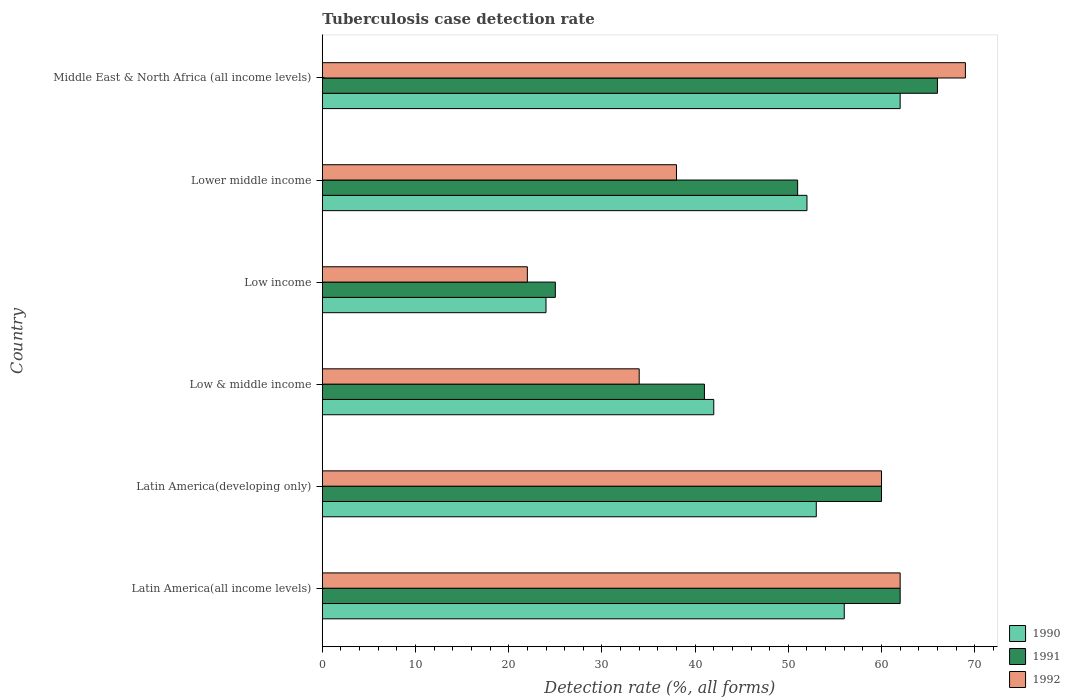How many different coloured bars are there?
Provide a short and direct response. 3. How many groups of bars are there?
Ensure brevity in your answer.  6. Are the number of bars per tick equal to the number of legend labels?
Give a very brief answer. Yes. Are the number of bars on each tick of the Y-axis equal?
Give a very brief answer. Yes. How many bars are there on the 5th tick from the bottom?
Provide a succinct answer. 3. Across all countries, what is the maximum tuberculosis case detection rate in in 1991?
Ensure brevity in your answer.  66. Across all countries, what is the minimum tuberculosis case detection rate in in 1991?
Give a very brief answer. 25. In which country was the tuberculosis case detection rate in in 1992 maximum?
Make the answer very short. Middle East & North Africa (all income levels). What is the total tuberculosis case detection rate in in 1991 in the graph?
Provide a succinct answer. 305. What is the average tuberculosis case detection rate in in 1992 per country?
Keep it short and to the point. 47.5. In how many countries, is the tuberculosis case detection rate in in 1990 greater than 60 %?
Provide a succinct answer. 1. What is the ratio of the tuberculosis case detection rate in in 1991 in Latin America(all income levels) to that in Middle East & North Africa (all income levels)?
Provide a succinct answer. 0.94. Is the difference between the tuberculosis case detection rate in in 1992 in Latin America(developing only) and Low income greater than the difference between the tuberculosis case detection rate in in 1991 in Latin America(developing only) and Low income?
Provide a succinct answer. Yes. Is the sum of the tuberculosis case detection rate in in 1991 in Lower middle income and Middle East & North Africa (all income levels) greater than the maximum tuberculosis case detection rate in in 1992 across all countries?
Make the answer very short. Yes. What does the 1st bar from the top in Middle East & North Africa (all income levels) represents?
Provide a short and direct response. 1992. How many bars are there?
Give a very brief answer. 18. Are all the bars in the graph horizontal?
Offer a terse response. Yes. How many countries are there in the graph?
Keep it short and to the point. 6. Does the graph contain any zero values?
Provide a short and direct response. No. How many legend labels are there?
Offer a terse response. 3. What is the title of the graph?
Make the answer very short. Tuberculosis case detection rate. Does "1999" appear as one of the legend labels in the graph?
Provide a succinct answer. No. What is the label or title of the X-axis?
Give a very brief answer. Detection rate (%, all forms). What is the Detection rate (%, all forms) of 1990 in Latin America(developing only)?
Keep it short and to the point. 53. What is the Detection rate (%, all forms) of 1991 in Latin America(developing only)?
Your answer should be compact. 60. What is the Detection rate (%, all forms) of 1991 in Low & middle income?
Give a very brief answer. 41. What is the Detection rate (%, all forms) in 1992 in Low & middle income?
Make the answer very short. 34. What is the Detection rate (%, all forms) in 1990 in Low income?
Your answer should be very brief. 24. What is the Detection rate (%, all forms) in 1992 in Low income?
Ensure brevity in your answer.  22. What is the Detection rate (%, all forms) in 1992 in Lower middle income?
Keep it short and to the point. 38. What is the Detection rate (%, all forms) of 1991 in Middle East & North Africa (all income levels)?
Provide a short and direct response. 66. What is the Detection rate (%, all forms) in 1992 in Middle East & North Africa (all income levels)?
Make the answer very short. 69. Across all countries, what is the maximum Detection rate (%, all forms) of 1990?
Your response must be concise. 62. Across all countries, what is the minimum Detection rate (%, all forms) in 1990?
Provide a succinct answer. 24. Across all countries, what is the minimum Detection rate (%, all forms) of 1991?
Keep it short and to the point. 25. What is the total Detection rate (%, all forms) in 1990 in the graph?
Your answer should be compact. 289. What is the total Detection rate (%, all forms) in 1991 in the graph?
Your answer should be compact. 305. What is the total Detection rate (%, all forms) in 1992 in the graph?
Offer a terse response. 285. What is the difference between the Detection rate (%, all forms) in 1990 in Latin America(all income levels) and that in Latin America(developing only)?
Keep it short and to the point. 3. What is the difference between the Detection rate (%, all forms) of 1991 in Latin America(all income levels) and that in Latin America(developing only)?
Offer a terse response. 2. What is the difference between the Detection rate (%, all forms) of 1992 in Latin America(all income levels) and that in Latin America(developing only)?
Ensure brevity in your answer.  2. What is the difference between the Detection rate (%, all forms) in 1991 in Latin America(all income levels) and that in Low & middle income?
Provide a succinct answer. 21. What is the difference between the Detection rate (%, all forms) in 1992 in Latin America(all income levels) and that in Low income?
Provide a short and direct response. 40. What is the difference between the Detection rate (%, all forms) of 1990 in Latin America(all income levels) and that in Lower middle income?
Your response must be concise. 4. What is the difference between the Detection rate (%, all forms) of 1991 in Latin America(all income levels) and that in Lower middle income?
Offer a terse response. 11. What is the difference between the Detection rate (%, all forms) in 1992 in Latin America(all income levels) and that in Lower middle income?
Your answer should be compact. 24. What is the difference between the Detection rate (%, all forms) in 1991 in Latin America(all income levels) and that in Middle East & North Africa (all income levels)?
Keep it short and to the point. -4. What is the difference between the Detection rate (%, all forms) of 1992 in Latin America(all income levels) and that in Middle East & North Africa (all income levels)?
Offer a very short reply. -7. What is the difference between the Detection rate (%, all forms) of 1990 in Latin America(developing only) and that in Low & middle income?
Your answer should be very brief. 11. What is the difference between the Detection rate (%, all forms) of 1991 in Latin America(developing only) and that in Low & middle income?
Offer a very short reply. 19. What is the difference between the Detection rate (%, all forms) of 1990 in Latin America(developing only) and that in Low income?
Keep it short and to the point. 29. What is the difference between the Detection rate (%, all forms) in 1992 in Latin America(developing only) and that in Low income?
Your response must be concise. 38. What is the difference between the Detection rate (%, all forms) of 1990 in Latin America(developing only) and that in Lower middle income?
Offer a terse response. 1. What is the difference between the Detection rate (%, all forms) in 1991 in Latin America(developing only) and that in Middle East & North Africa (all income levels)?
Keep it short and to the point. -6. What is the difference between the Detection rate (%, all forms) of 1992 in Latin America(developing only) and that in Middle East & North Africa (all income levels)?
Your response must be concise. -9. What is the difference between the Detection rate (%, all forms) in 1990 in Low & middle income and that in Low income?
Give a very brief answer. 18. What is the difference between the Detection rate (%, all forms) of 1990 in Low & middle income and that in Lower middle income?
Your answer should be compact. -10. What is the difference between the Detection rate (%, all forms) of 1992 in Low & middle income and that in Lower middle income?
Provide a succinct answer. -4. What is the difference between the Detection rate (%, all forms) in 1991 in Low & middle income and that in Middle East & North Africa (all income levels)?
Offer a terse response. -25. What is the difference between the Detection rate (%, all forms) of 1992 in Low & middle income and that in Middle East & North Africa (all income levels)?
Your answer should be compact. -35. What is the difference between the Detection rate (%, all forms) of 1992 in Low income and that in Lower middle income?
Your response must be concise. -16. What is the difference between the Detection rate (%, all forms) in 1990 in Low income and that in Middle East & North Africa (all income levels)?
Provide a short and direct response. -38. What is the difference between the Detection rate (%, all forms) in 1991 in Low income and that in Middle East & North Africa (all income levels)?
Keep it short and to the point. -41. What is the difference between the Detection rate (%, all forms) of 1992 in Low income and that in Middle East & North Africa (all income levels)?
Your response must be concise. -47. What is the difference between the Detection rate (%, all forms) in 1990 in Lower middle income and that in Middle East & North Africa (all income levels)?
Your answer should be very brief. -10. What is the difference between the Detection rate (%, all forms) in 1992 in Lower middle income and that in Middle East & North Africa (all income levels)?
Offer a very short reply. -31. What is the difference between the Detection rate (%, all forms) in 1991 in Latin America(all income levels) and the Detection rate (%, all forms) in 1992 in Latin America(developing only)?
Offer a terse response. 2. What is the difference between the Detection rate (%, all forms) of 1990 in Latin America(all income levels) and the Detection rate (%, all forms) of 1991 in Low & middle income?
Make the answer very short. 15. What is the difference between the Detection rate (%, all forms) of 1990 in Latin America(all income levels) and the Detection rate (%, all forms) of 1992 in Low & middle income?
Make the answer very short. 22. What is the difference between the Detection rate (%, all forms) in 1991 in Latin America(all income levels) and the Detection rate (%, all forms) in 1992 in Low & middle income?
Keep it short and to the point. 28. What is the difference between the Detection rate (%, all forms) in 1990 in Latin America(all income levels) and the Detection rate (%, all forms) in 1992 in Low income?
Provide a succinct answer. 34. What is the difference between the Detection rate (%, all forms) of 1990 in Latin America(all income levels) and the Detection rate (%, all forms) of 1991 in Lower middle income?
Give a very brief answer. 5. What is the difference between the Detection rate (%, all forms) in 1990 in Latin America(all income levels) and the Detection rate (%, all forms) in 1992 in Lower middle income?
Provide a short and direct response. 18. What is the difference between the Detection rate (%, all forms) in 1990 in Latin America(all income levels) and the Detection rate (%, all forms) in 1991 in Middle East & North Africa (all income levels)?
Your response must be concise. -10. What is the difference between the Detection rate (%, all forms) of 1991 in Latin America(all income levels) and the Detection rate (%, all forms) of 1992 in Middle East & North Africa (all income levels)?
Offer a very short reply. -7. What is the difference between the Detection rate (%, all forms) in 1990 in Latin America(developing only) and the Detection rate (%, all forms) in 1991 in Low income?
Keep it short and to the point. 28. What is the difference between the Detection rate (%, all forms) in 1990 in Latin America(developing only) and the Detection rate (%, all forms) in 1992 in Low income?
Offer a terse response. 31. What is the difference between the Detection rate (%, all forms) of 1990 in Latin America(developing only) and the Detection rate (%, all forms) of 1991 in Lower middle income?
Provide a short and direct response. 2. What is the difference between the Detection rate (%, all forms) in 1991 in Latin America(developing only) and the Detection rate (%, all forms) in 1992 in Lower middle income?
Your answer should be very brief. 22. What is the difference between the Detection rate (%, all forms) of 1990 in Latin America(developing only) and the Detection rate (%, all forms) of 1991 in Middle East & North Africa (all income levels)?
Keep it short and to the point. -13. What is the difference between the Detection rate (%, all forms) in 1990 in Latin America(developing only) and the Detection rate (%, all forms) in 1992 in Middle East & North Africa (all income levels)?
Your answer should be very brief. -16. What is the difference between the Detection rate (%, all forms) of 1991 in Latin America(developing only) and the Detection rate (%, all forms) of 1992 in Middle East & North Africa (all income levels)?
Your answer should be very brief. -9. What is the difference between the Detection rate (%, all forms) of 1990 in Low & middle income and the Detection rate (%, all forms) of 1992 in Low income?
Your response must be concise. 20. What is the difference between the Detection rate (%, all forms) in 1991 in Low & middle income and the Detection rate (%, all forms) in 1992 in Low income?
Make the answer very short. 19. What is the difference between the Detection rate (%, all forms) of 1990 in Low & middle income and the Detection rate (%, all forms) of 1991 in Lower middle income?
Offer a very short reply. -9. What is the difference between the Detection rate (%, all forms) of 1990 in Low & middle income and the Detection rate (%, all forms) of 1992 in Lower middle income?
Offer a very short reply. 4. What is the difference between the Detection rate (%, all forms) of 1990 in Low & middle income and the Detection rate (%, all forms) of 1991 in Middle East & North Africa (all income levels)?
Provide a succinct answer. -24. What is the difference between the Detection rate (%, all forms) of 1990 in Low & middle income and the Detection rate (%, all forms) of 1992 in Middle East & North Africa (all income levels)?
Ensure brevity in your answer.  -27. What is the difference between the Detection rate (%, all forms) in 1991 in Low income and the Detection rate (%, all forms) in 1992 in Lower middle income?
Make the answer very short. -13. What is the difference between the Detection rate (%, all forms) of 1990 in Low income and the Detection rate (%, all forms) of 1991 in Middle East & North Africa (all income levels)?
Provide a short and direct response. -42. What is the difference between the Detection rate (%, all forms) of 1990 in Low income and the Detection rate (%, all forms) of 1992 in Middle East & North Africa (all income levels)?
Give a very brief answer. -45. What is the difference between the Detection rate (%, all forms) of 1991 in Low income and the Detection rate (%, all forms) of 1992 in Middle East & North Africa (all income levels)?
Make the answer very short. -44. What is the difference between the Detection rate (%, all forms) in 1990 in Lower middle income and the Detection rate (%, all forms) in 1991 in Middle East & North Africa (all income levels)?
Make the answer very short. -14. What is the difference between the Detection rate (%, all forms) in 1991 in Lower middle income and the Detection rate (%, all forms) in 1992 in Middle East & North Africa (all income levels)?
Your answer should be compact. -18. What is the average Detection rate (%, all forms) of 1990 per country?
Give a very brief answer. 48.17. What is the average Detection rate (%, all forms) of 1991 per country?
Give a very brief answer. 50.83. What is the average Detection rate (%, all forms) of 1992 per country?
Make the answer very short. 47.5. What is the difference between the Detection rate (%, all forms) of 1990 and Detection rate (%, all forms) of 1991 in Latin America(developing only)?
Give a very brief answer. -7. What is the difference between the Detection rate (%, all forms) of 1990 and Detection rate (%, all forms) of 1991 in Low & middle income?
Offer a terse response. 1. What is the difference between the Detection rate (%, all forms) in 1991 and Detection rate (%, all forms) in 1992 in Low & middle income?
Ensure brevity in your answer.  7. What is the difference between the Detection rate (%, all forms) of 1990 and Detection rate (%, all forms) of 1991 in Low income?
Offer a terse response. -1. What is the difference between the Detection rate (%, all forms) in 1990 and Detection rate (%, all forms) in 1991 in Lower middle income?
Offer a terse response. 1. What is the difference between the Detection rate (%, all forms) in 1991 and Detection rate (%, all forms) in 1992 in Lower middle income?
Your answer should be very brief. 13. What is the difference between the Detection rate (%, all forms) of 1990 and Detection rate (%, all forms) of 1991 in Middle East & North Africa (all income levels)?
Give a very brief answer. -4. What is the difference between the Detection rate (%, all forms) of 1990 and Detection rate (%, all forms) of 1992 in Middle East & North Africa (all income levels)?
Give a very brief answer. -7. What is the ratio of the Detection rate (%, all forms) in 1990 in Latin America(all income levels) to that in Latin America(developing only)?
Offer a terse response. 1.06. What is the ratio of the Detection rate (%, all forms) of 1991 in Latin America(all income levels) to that in Latin America(developing only)?
Give a very brief answer. 1.03. What is the ratio of the Detection rate (%, all forms) in 1992 in Latin America(all income levels) to that in Latin America(developing only)?
Make the answer very short. 1.03. What is the ratio of the Detection rate (%, all forms) in 1990 in Latin America(all income levels) to that in Low & middle income?
Provide a succinct answer. 1.33. What is the ratio of the Detection rate (%, all forms) in 1991 in Latin America(all income levels) to that in Low & middle income?
Your answer should be compact. 1.51. What is the ratio of the Detection rate (%, all forms) in 1992 in Latin America(all income levels) to that in Low & middle income?
Offer a terse response. 1.82. What is the ratio of the Detection rate (%, all forms) in 1990 in Latin America(all income levels) to that in Low income?
Ensure brevity in your answer.  2.33. What is the ratio of the Detection rate (%, all forms) of 1991 in Latin America(all income levels) to that in Low income?
Provide a short and direct response. 2.48. What is the ratio of the Detection rate (%, all forms) in 1992 in Latin America(all income levels) to that in Low income?
Offer a very short reply. 2.82. What is the ratio of the Detection rate (%, all forms) in 1990 in Latin America(all income levels) to that in Lower middle income?
Your answer should be compact. 1.08. What is the ratio of the Detection rate (%, all forms) of 1991 in Latin America(all income levels) to that in Lower middle income?
Make the answer very short. 1.22. What is the ratio of the Detection rate (%, all forms) of 1992 in Latin America(all income levels) to that in Lower middle income?
Provide a short and direct response. 1.63. What is the ratio of the Detection rate (%, all forms) of 1990 in Latin America(all income levels) to that in Middle East & North Africa (all income levels)?
Keep it short and to the point. 0.9. What is the ratio of the Detection rate (%, all forms) of 1991 in Latin America(all income levels) to that in Middle East & North Africa (all income levels)?
Give a very brief answer. 0.94. What is the ratio of the Detection rate (%, all forms) in 1992 in Latin America(all income levels) to that in Middle East & North Africa (all income levels)?
Provide a short and direct response. 0.9. What is the ratio of the Detection rate (%, all forms) of 1990 in Latin America(developing only) to that in Low & middle income?
Offer a terse response. 1.26. What is the ratio of the Detection rate (%, all forms) in 1991 in Latin America(developing only) to that in Low & middle income?
Your answer should be compact. 1.46. What is the ratio of the Detection rate (%, all forms) in 1992 in Latin America(developing only) to that in Low & middle income?
Keep it short and to the point. 1.76. What is the ratio of the Detection rate (%, all forms) of 1990 in Latin America(developing only) to that in Low income?
Provide a succinct answer. 2.21. What is the ratio of the Detection rate (%, all forms) of 1992 in Latin America(developing only) to that in Low income?
Give a very brief answer. 2.73. What is the ratio of the Detection rate (%, all forms) of 1990 in Latin America(developing only) to that in Lower middle income?
Give a very brief answer. 1.02. What is the ratio of the Detection rate (%, all forms) of 1991 in Latin America(developing only) to that in Lower middle income?
Provide a short and direct response. 1.18. What is the ratio of the Detection rate (%, all forms) of 1992 in Latin America(developing only) to that in Lower middle income?
Provide a succinct answer. 1.58. What is the ratio of the Detection rate (%, all forms) in 1990 in Latin America(developing only) to that in Middle East & North Africa (all income levels)?
Provide a succinct answer. 0.85. What is the ratio of the Detection rate (%, all forms) of 1992 in Latin America(developing only) to that in Middle East & North Africa (all income levels)?
Provide a succinct answer. 0.87. What is the ratio of the Detection rate (%, all forms) in 1991 in Low & middle income to that in Low income?
Your answer should be very brief. 1.64. What is the ratio of the Detection rate (%, all forms) in 1992 in Low & middle income to that in Low income?
Give a very brief answer. 1.55. What is the ratio of the Detection rate (%, all forms) in 1990 in Low & middle income to that in Lower middle income?
Ensure brevity in your answer.  0.81. What is the ratio of the Detection rate (%, all forms) in 1991 in Low & middle income to that in Lower middle income?
Offer a terse response. 0.8. What is the ratio of the Detection rate (%, all forms) in 1992 in Low & middle income to that in Lower middle income?
Your response must be concise. 0.89. What is the ratio of the Detection rate (%, all forms) in 1990 in Low & middle income to that in Middle East & North Africa (all income levels)?
Ensure brevity in your answer.  0.68. What is the ratio of the Detection rate (%, all forms) of 1991 in Low & middle income to that in Middle East & North Africa (all income levels)?
Offer a terse response. 0.62. What is the ratio of the Detection rate (%, all forms) of 1992 in Low & middle income to that in Middle East & North Africa (all income levels)?
Give a very brief answer. 0.49. What is the ratio of the Detection rate (%, all forms) in 1990 in Low income to that in Lower middle income?
Ensure brevity in your answer.  0.46. What is the ratio of the Detection rate (%, all forms) of 1991 in Low income to that in Lower middle income?
Make the answer very short. 0.49. What is the ratio of the Detection rate (%, all forms) of 1992 in Low income to that in Lower middle income?
Offer a very short reply. 0.58. What is the ratio of the Detection rate (%, all forms) of 1990 in Low income to that in Middle East & North Africa (all income levels)?
Your response must be concise. 0.39. What is the ratio of the Detection rate (%, all forms) in 1991 in Low income to that in Middle East & North Africa (all income levels)?
Your answer should be compact. 0.38. What is the ratio of the Detection rate (%, all forms) of 1992 in Low income to that in Middle East & North Africa (all income levels)?
Your response must be concise. 0.32. What is the ratio of the Detection rate (%, all forms) of 1990 in Lower middle income to that in Middle East & North Africa (all income levels)?
Offer a very short reply. 0.84. What is the ratio of the Detection rate (%, all forms) of 1991 in Lower middle income to that in Middle East & North Africa (all income levels)?
Offer a very short reply. 0.77. What is the ratio of the Detection rate (%, all forms) of 1992 in Lower middle income to that in Middle East & North Africa (all income levels)?
Your answer should be compact. 0.55. What is the difference between the highest and the second highest Detection rate (%, all forms) of 1991?
Offer a terse response. 4. What is the difference between the highest and the second highest Detection rate (%, all forms) in 1992?
Offer a terse response. 7. 